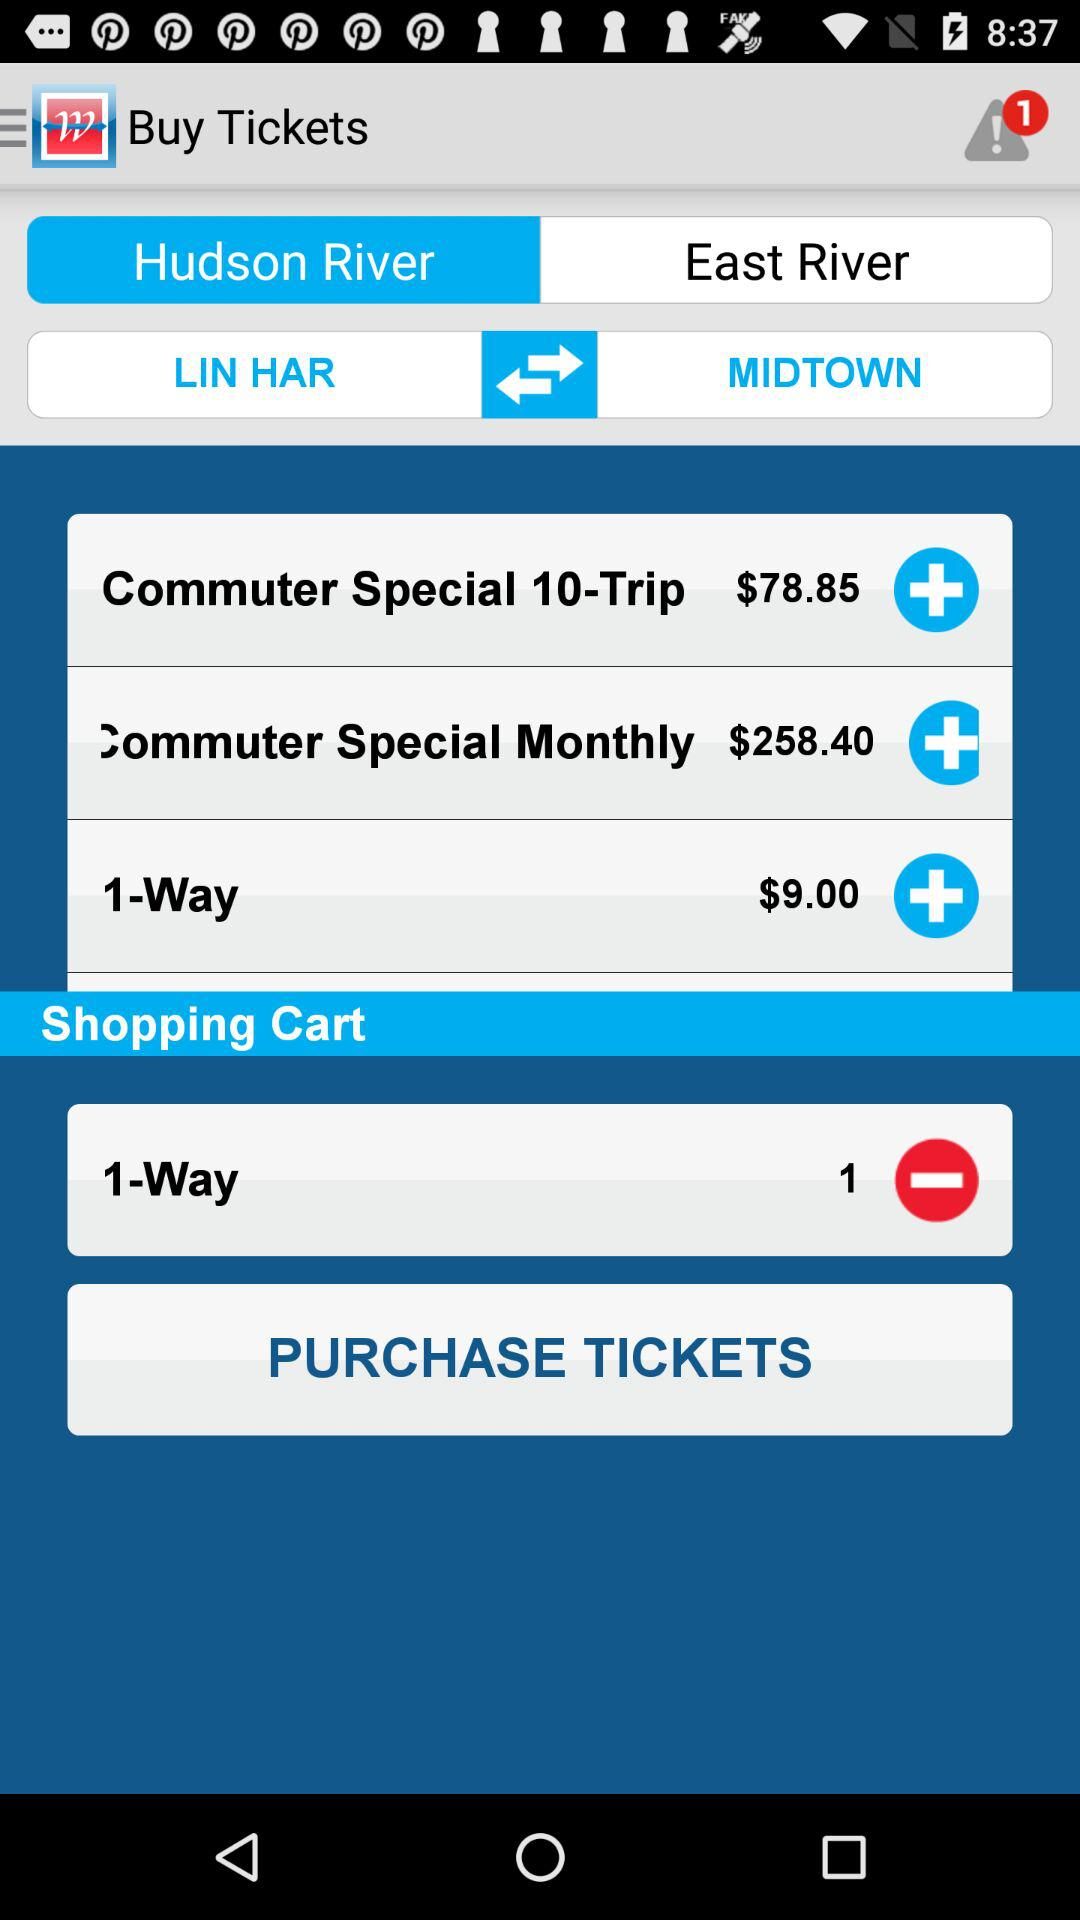Which trip is added to the shopping cart? The trip that is added to the shopping cart is "1-Way". 